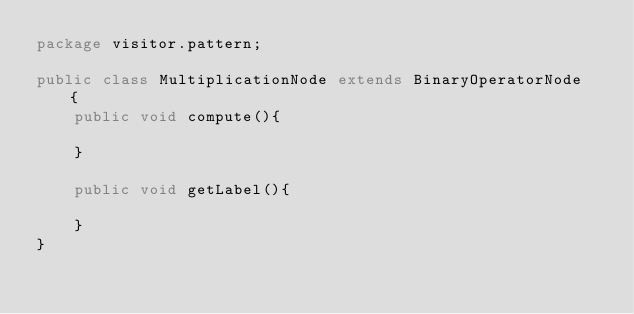<code> <loc_0><loc_0><loc_500><loc_500><_Java_>package visitor.pattern;

public class MultiplicationNode extends BinaryOperatorNode  {
    public void compute(){

    }

    public void getLabel(){

    }
}
</code> 